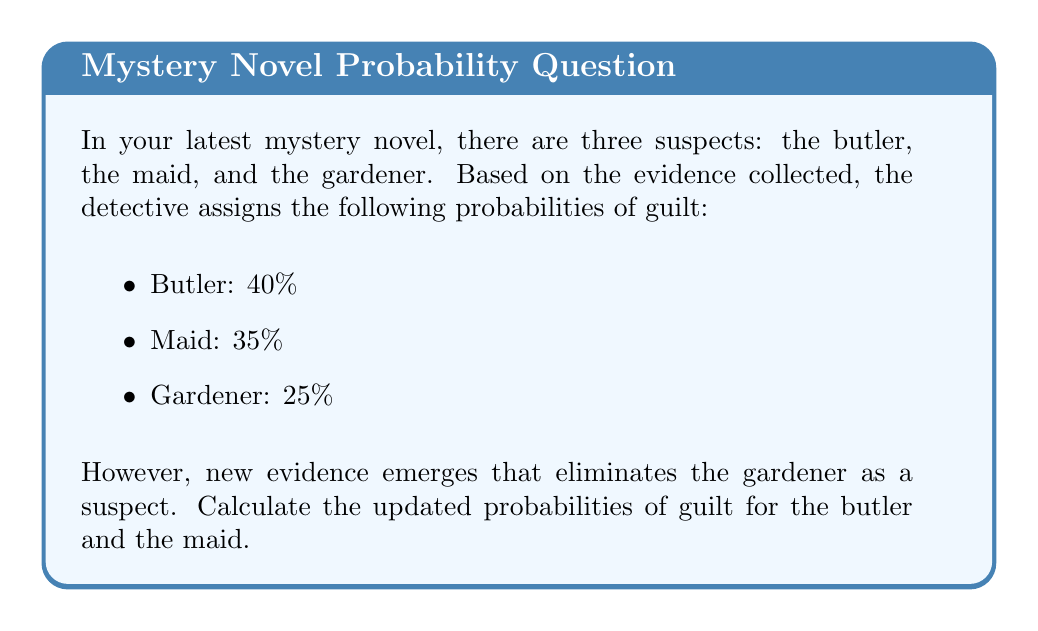Help me with this question. Let's approach this step-by-step:

1) Initially, we have:
   $P(\text{Butler}) = 0.40$
   $P(\text{Maid}) = 0.35$
   $P(\text{Gardener}) = 0.25$

2) The sum of these probabilities is 1 (or 100%), which is correct.

3) When the gardener is eliminated, we need to redistribute the probabilities between the butler and the maid. This is done using the concept of conditional probability.

4) We can calculate the new probabilities using the formula:
   $P(\text{Suspect} | \text{Not Gardener}) = \frac{P(\text{Suspect})}{1 - P(\text{Gardener})}$

5) For the butler:
   $P(\text{Butler} | \text{Not Gardener}) = \frac{0.40}{1 - 0.25} = \frac{0.40}{0.75} = \frac{4}{7.5} \approx 0.5333$

6) For the maid:
   $P(\text{Maid} | \text{Not Gardener}) = \frac{0.35}{1 - 0.25} = \frac{0.35}{0.75} = \frac{3.5}{7.5} \approx 0.4667$

7) We can verify that these new probabilities sum to 1:
   $0.5333 + 0.4667 = 1$

Therefore, the updated probabilities are approximately 53.33% for the butler and 46.67% for the maid.
Answer: Butler: $\frac{4}{7.5} \approx 53.33\%$, Maid: $\frac{3.5}{7.5} \approx 46.67\%$ 